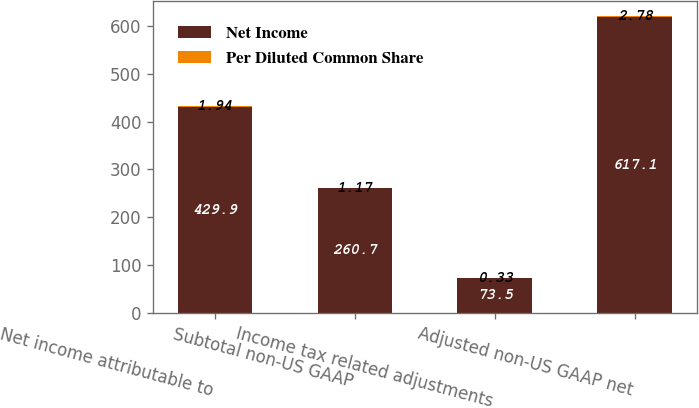Convert chart to OTSL. <chart><loc_0><loc_0><loc_500><loc_500><stacked_bar_chart><ecel><fcel>Net income attributable to<fcel>Subtotal non-US GAAP<fcel>Income tax related adjustments<fcel>Adjusted non-US GAAP net<nl><fcel>Net Income<fcel>429.9<fcel>260.7<fcel>73.5<fcel>617.1<nl><fcel>Per Diluted Common Share<fcel>1.94<fcel>1.17<fcel>0.33<fcel>2.78<nl></chart> 